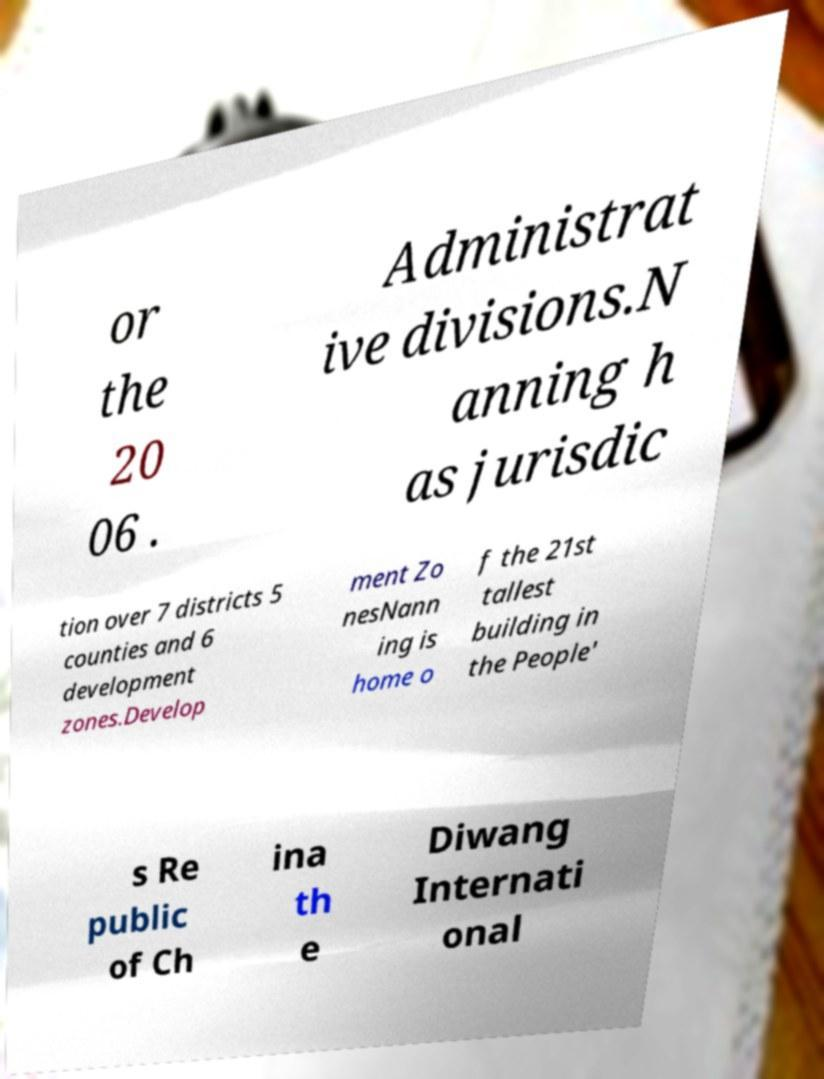What messages or text are displayed in this image? I need them in a readable, typed format. or the 20 06 . Administrat ive divisions.N anning h as jurisdic tion over 7 districts 5 counties and 6 development zones.Develop ment Zo nesNann ing is home o f the 21st tallest building in the People' s Re public of Ch ina th e Diwang Internati onal 